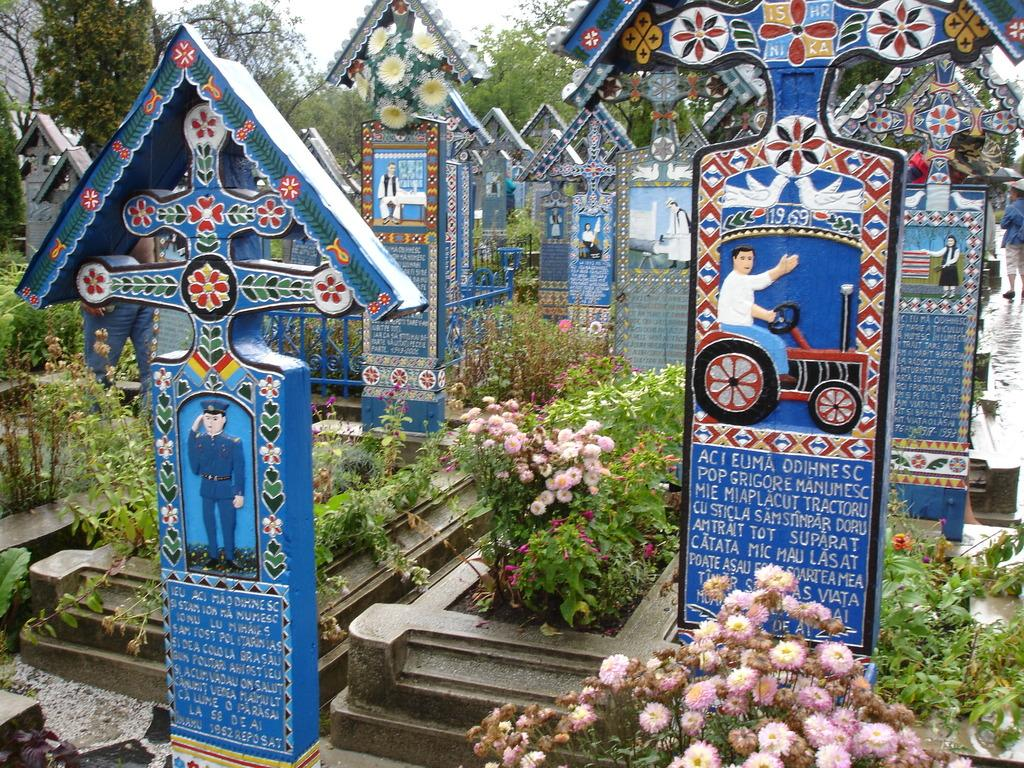What type of location is depicted in the image? The image contains cemeteries. What type of vegetation can be seen in the image? There are plants and trees visible in the image. Are there any flowers present? Yes, there are flowers in the image. What can be seen at the top of the image? Trees, a wall, and the sky are visible at the top of the image. How long does it take for the birthday celebration to happen in the image? There is no birthday celebration depicted in the image, so it is not possible to determine how long it takes. Can you see a bike in the image? No, there is no bike present in the image. 